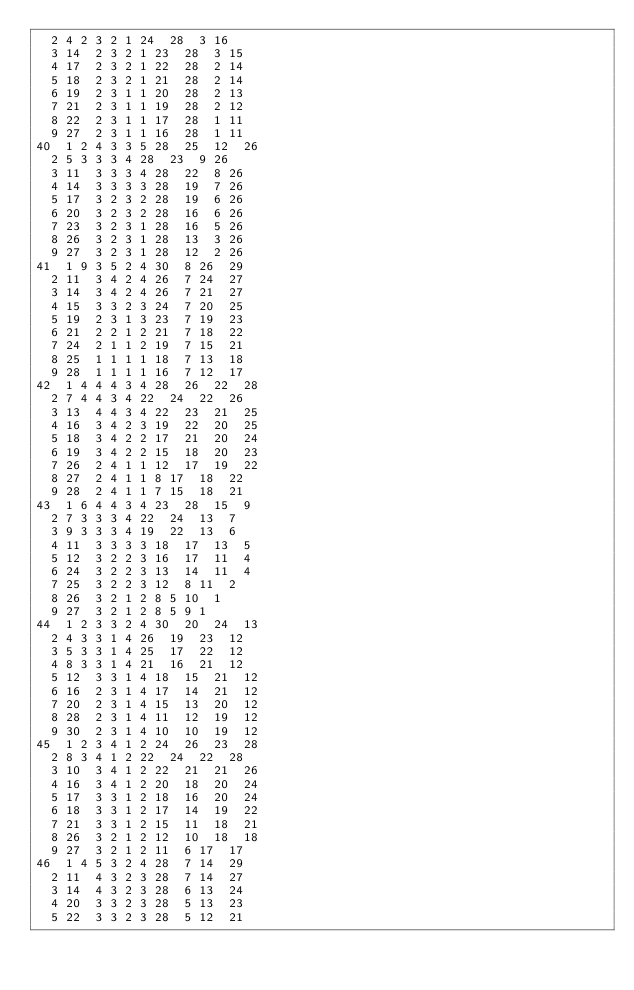Convert code to text. <code><loc_0><loc_0><loc_500><loc_500><_ObjectiveC_>	2	4	2	3	2	1	24	28	3	16	
	3	14	2	3	2	1	23	28	3	15	
	4	17	2	3	2	1	22	28	2	14	
	5	18	2	3	2	1	21	28	2	14	
	6	19	2	3	1	1	20	28	2	13	
	7	21	2	3	1	1	19	28	2	12	
	8	22	2	3	1	1	17	28	1	11	
	9	27	2	3	1	1	16	28	1	11	
40	1	2	4	3	3	5	28	25	12	26	
	2	5	3	3	3	4	28	23	9	26	
	3	11	3	3	3	4	28	22	8	26	
	4	14	3	3	3	3	28	19	7	26	
	5	17	3	2	3	2	28	19	6	26	
	6	20	3	2	3	2	28	16	6	26	
	7	23	3	2	3	1	28	16	5	26	
	8	26	3	2	3	1	28	13	3	26	
	9	27	3	2	3	1	28	12	2	26	
41	1	9	3	5	2	4	30	8	26	29	
	2	11	3	4	2	4	26	7	24	27	
	3	14	3	4	2	4	26	7	21	27	
	4	15	3	3	2	3	24	7	20	25	
	5	19	2	3	1	3	23	7	19	23	
	6	21	2	2	1	2	21	7	18	22	
	7	24	2	1	1	2	19	7	15	21	
	8	25	1	1	1	1	18	7	13	18	
	9	28	1	1	1	1	16	7	12	17	
42	1	4	4	4	3	4	28	26	22	28	
	2	7	4	4	3	4	22	24	22	26	
	3	13	4	4	3	4	22	23	21	25	
	4	16	3	4	2	3	19	22	20	25	
	5	18	3	4	2	2	17	21	20	24	
	6	19	3	4	2	2	15	18	20	23	
	7	26	2	4	1	1	12	17	19	22	
	8	27	2	4	1	1	8	17	18	22	
	9	28	2	4	1	1	7	15	18	21	
43	1	6	4	4	3	4	23	28	15	9	
	2	7	3	3	3	4	22	24	13	7	
	3	9	3	3	3	4	19	22	13	6	
	4	11	3	3	3	3	18	17	13	5	
	5	12	3	2	2	3	16	17	11	4	
	6	24	3	2	2	3	13	14	11	4	
	7	25	3	2	2	3	12	8	11	2	
	8	26	3	2	1	2	8	5	10	1	
	9	27	3	2	1	2	8	5	9	1	
44	1	2	3	3	2	4	30	20	24	13	
	2	4	3	3	1	4	26	19	23	12	
	3	5	3	3	1	4	25	17	22	12	
	4	8	3	3	1	4	21	16	21	12	
	5	12	3	3	1	4	18	15	21	12	
	6	16	2	3	1	4	17	14	21	12	
	7	20	2	3	1	4	15	13	20	12	
	8	28	2	3	1	4	11	12	19	12	
	9	30	2	3	1	4	10	10	19	12	
45	1	2	3	4	1	2	24	26	23	28	
	2	8	3	4	1	2	22	24	22	28	
	3	10	3	4	1	2	22	21	21	26	
	4	16	3	4	1	2	20	18	20	24	
	5	17	3	3	1	2	18	16	20	24	
	6	18	3	3	1	2	17	14	19	22	
	7	21	3	3	1	2	15	11	18	21	
	8	26	3	2	1	2	12	10	18	18	
	9	27	3	2	1	2	11	6	17	17	
46	1	4	5	3	2	4	28	7	14	29	
	2	11	4	3	2	3	28	7	14	27	
	3	14	4	3	2	3	28	6	13	24	
	4	20	3	3	2	3	28	5	13	23	
	5	22	3	3	2	3	28	5	12	21	</code> 